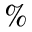<formula> <loc_0><loc_0><loc_500><loc_500>\%</formula> 